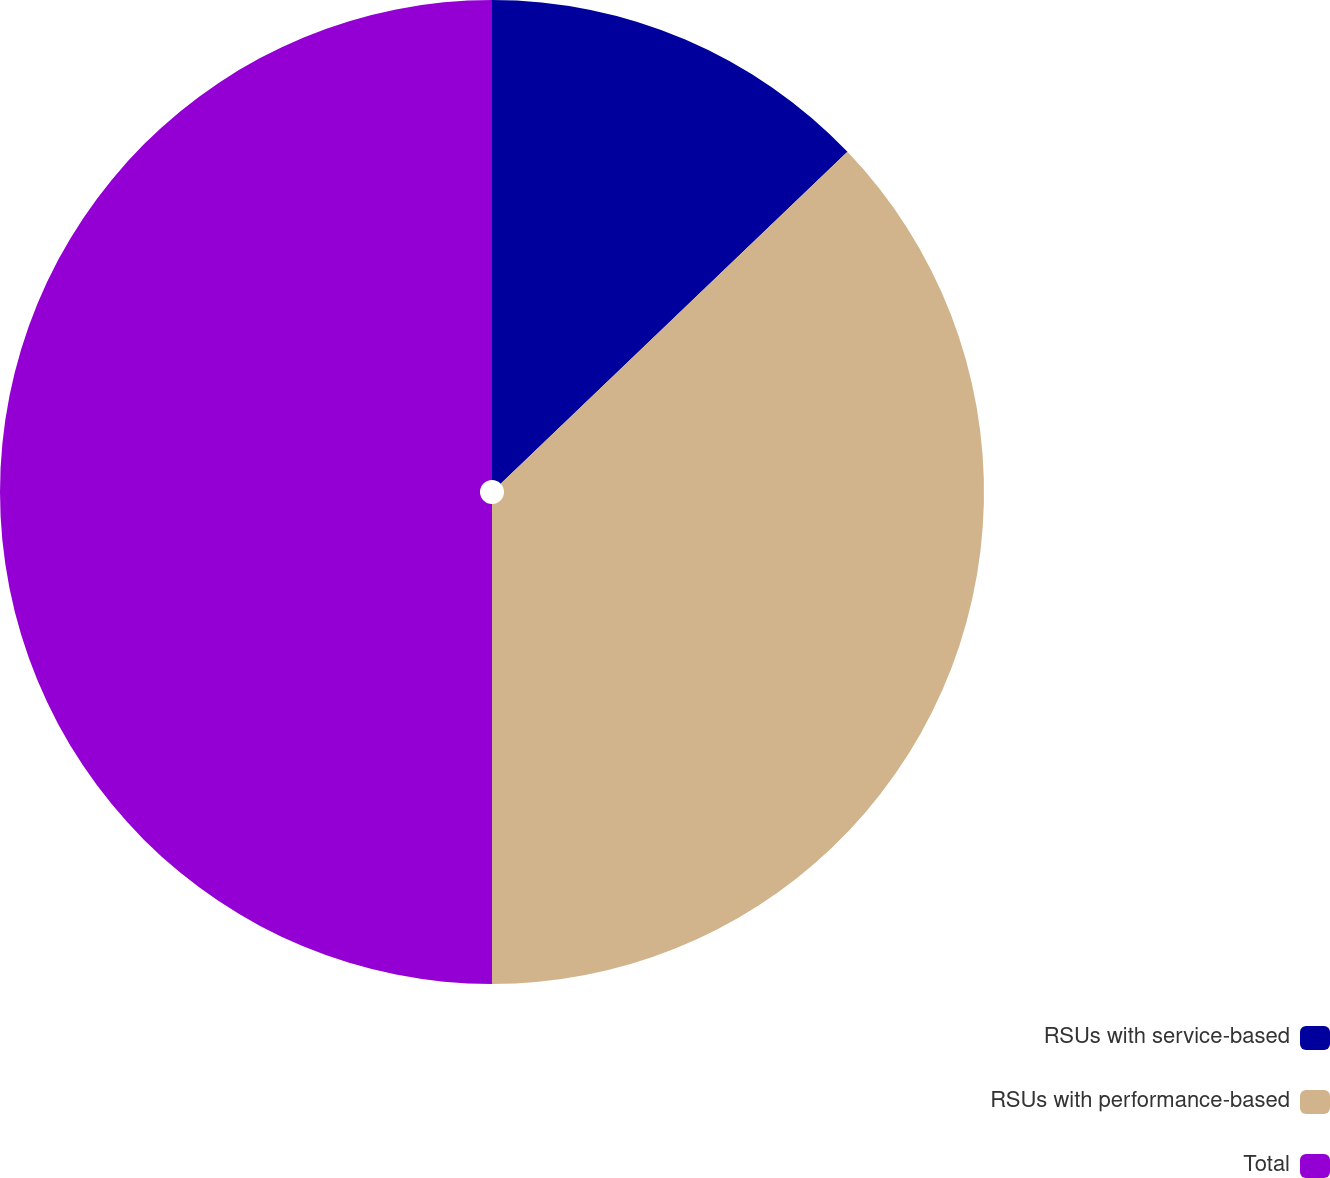Convert chart to OTSL. <chart><loc_0><loc_0><loc_500><loc_500><pie_chart><fcel>RSUs with service-based<fcel>RSUs with performance-based<fcel>Total<nl><fcel>12.85%<fcel>37.15%<fcel>50.0%<nl></chart> 